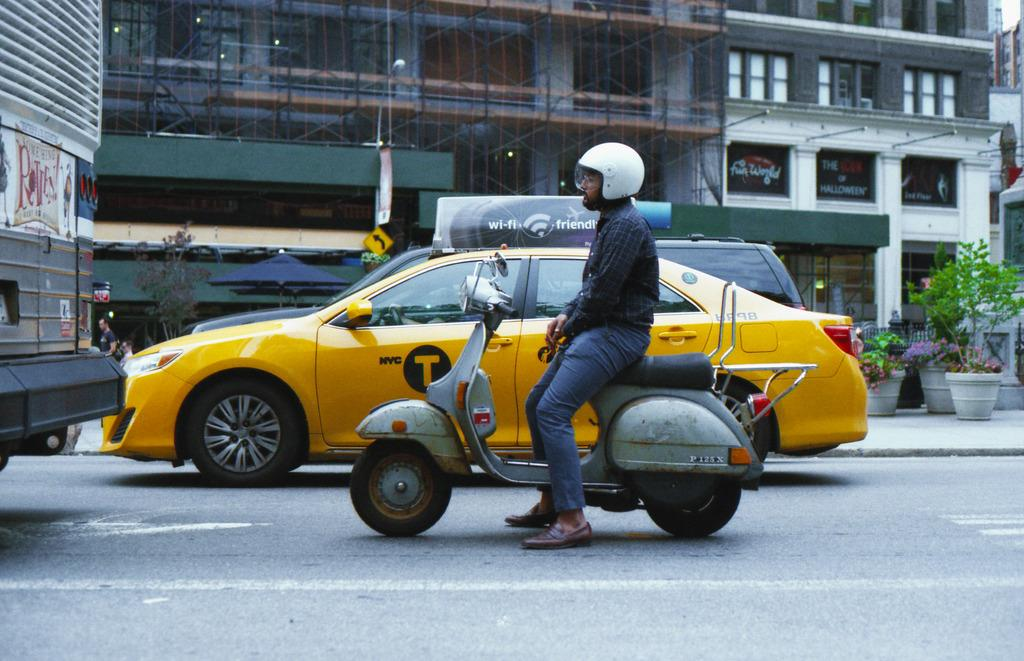<image>
Relay a brief, clear account of the picture shown. a person next to a taxi with the letter T 